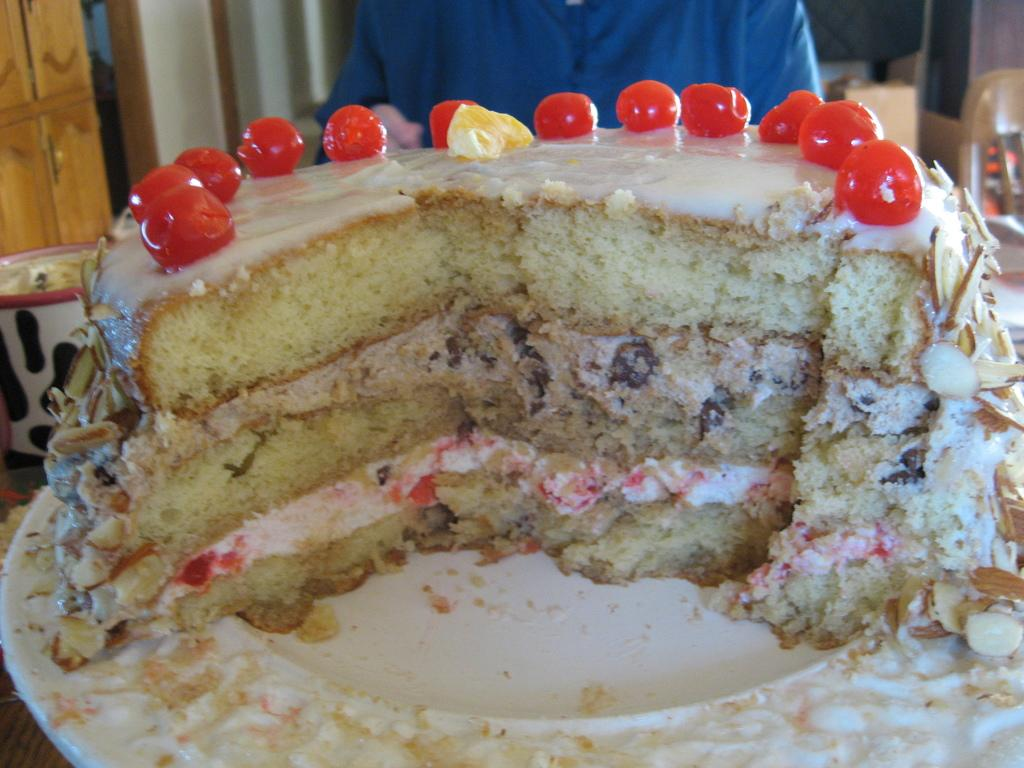What is the main object on the plate in the image? There is a cake on a plate in the image. Can you describe the person in the image? There is a person in the image, but their appearance or actions are not specified. What architectural feature can be seen in the image? There is a door in the image. What else can be seen in the background of the image? There are other unspecified elements in the background of the image. What type of hydrant is visible in the image? There is no hydrant present in the image. How many scissors are being used to cut the cake in the image? There is no indication of scissors or cake-cutting in the image. 